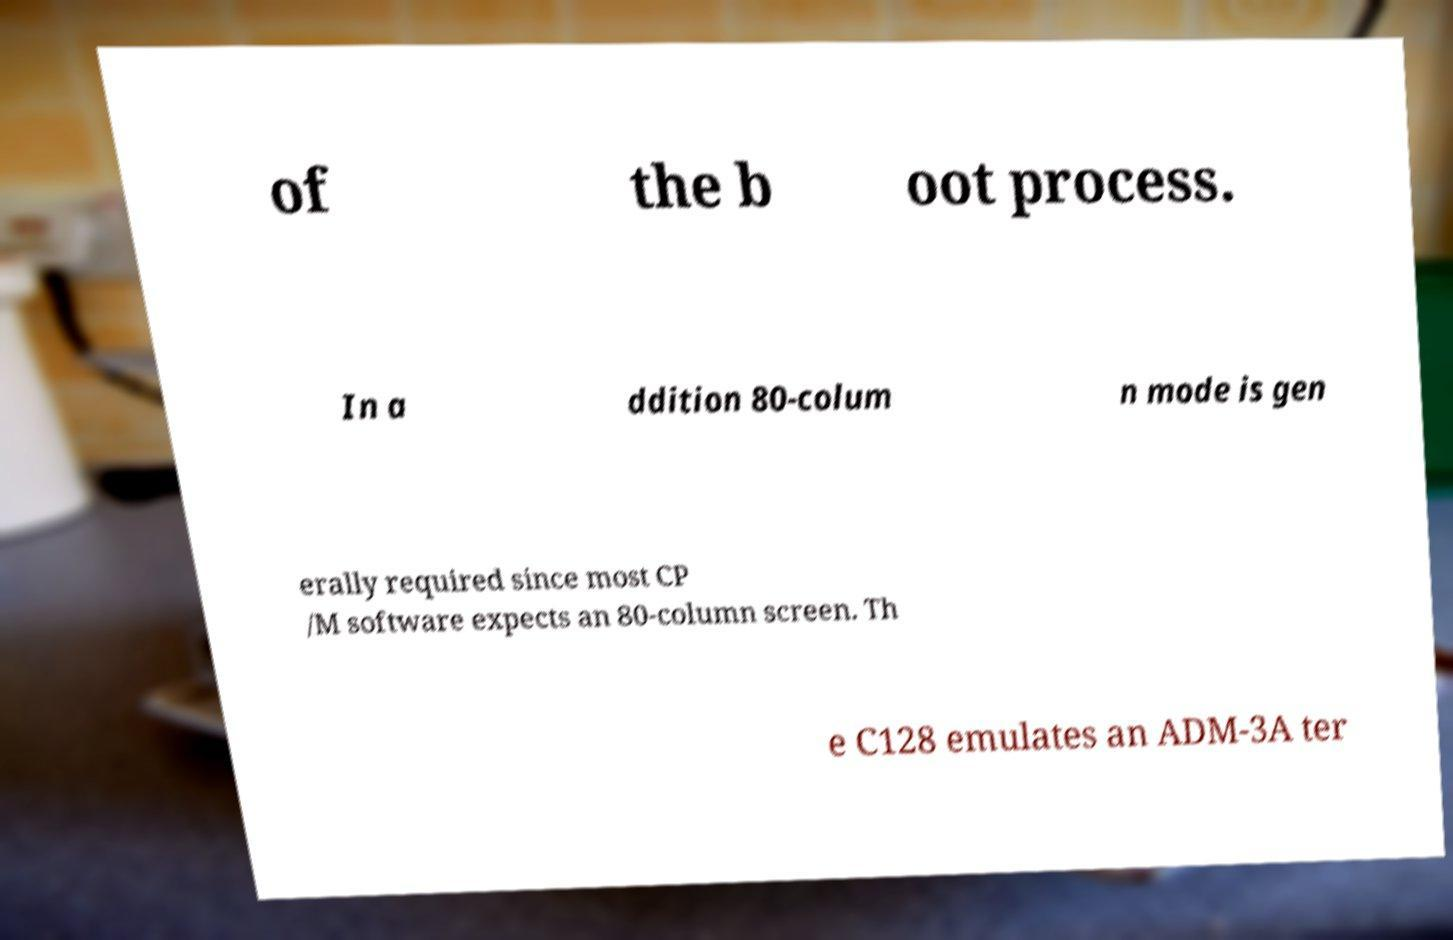There's text embedded in this image that I need extracted. Can you transcribe it verbatim? of the b oot process. In a ddition 80-colum n mode is gen erally required since most CP /M software expects an 80-column screen. Th e C128 emulates an ADM-3A ter 